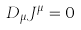<formula> <loc_0><loc_0><loc_500><loc_500>D _ { \mu } J ^ { \mu } = 0</formula> 